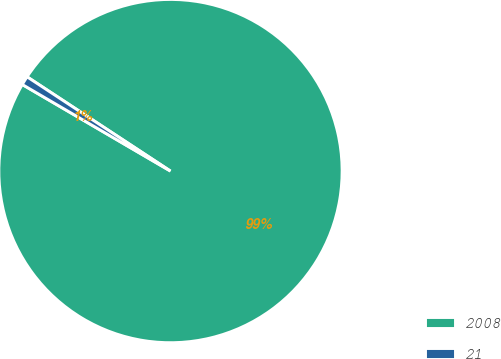Convert chart. <chart><loc_0><loc_0><loc_500><loc_500><pie_chart><fcel>2008<fcel>21<nl><fcel>99.16%<fcel>0.84%<nl></chart> 